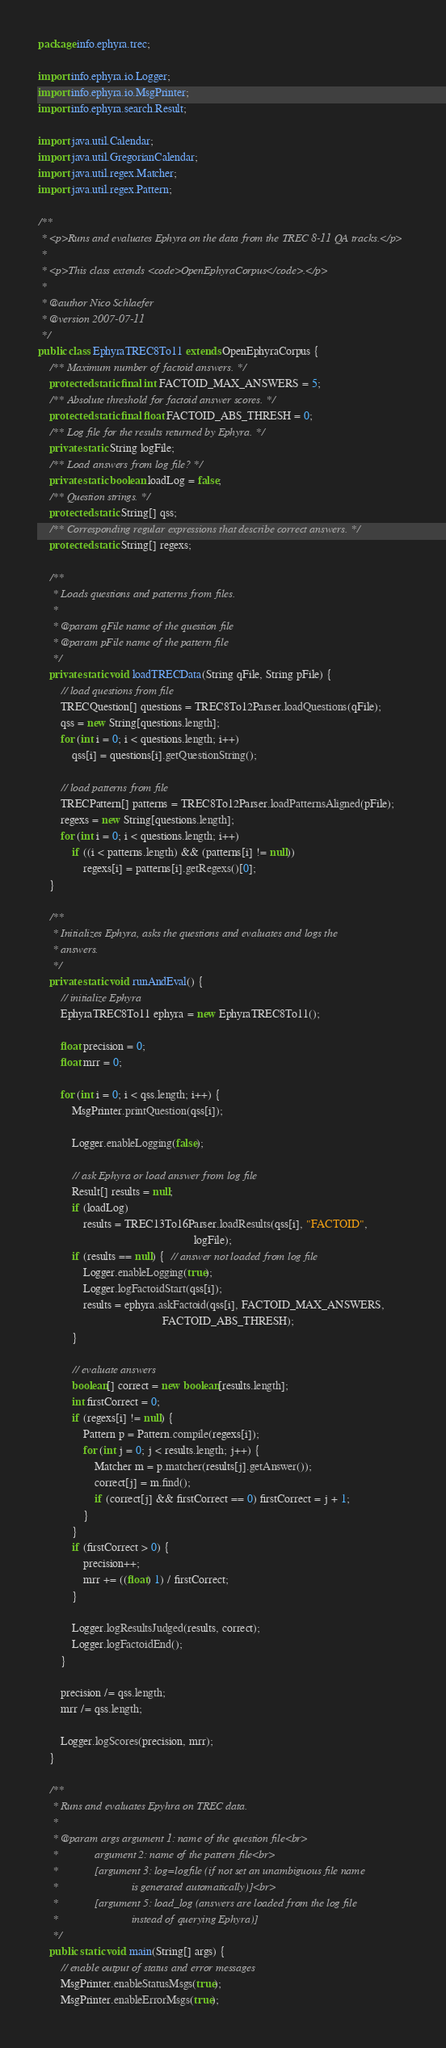<code> <loc_0><loc_0><loc_500><loc_500><_Java_>package info.ephyra.trec;

import info.ephyra.io.Logger;
import info.ephyra.io.MsgPrinter;
import info.ephyra.search.Result;

import java.util.Calendar;
import java.util.GregorianCalendar;
import java.util.regex.Matcher;
import java.util.regex.Pattern;

/**
 * <p>Runs and evaluates Ephyra on the data from the TREC 8-11 QA tracks.</p>
 * 
 * <p>This class extends <code>OpenEphyraCorpus</code>.</p>
 * 
 * @author Nico Schlaefer
 * @version 2007-07-11
 */
public class EphyraTREC8To11 extends OpenEphyraCorpus {
	/** Maximum number of factoid answers. */
	protected static final int FACTOID_MAX_ANSWERS = 5;
	/** Absolute threshold for factoid answer scores. */
	protected static final float FACTOID_ABS_THRESH = 0;
	/** Log file for the results returned by Ephyra. */
	private static String logFile;
	/** Load answers from log file? */
	private static boolean loadLog = false;
	/** Question strings. */
	protected static String[] qss;
	/** Corresponding regular expressions that describe correct answers. */
	protected static String[] regexs;
	
	/**
	 * Loads questions and patterns from files.
	 * 
	 * @param qFile name of the question file
	 * @param pFile name of the pattern file
	 */
	private static void loadTRECData(String qFile, String pFile) {
		// load questions from file
		TRECQuestion[] questions = TREC8To12Parser.loadQuestions(qFile);
		qss = new String[questions.length];
		for (int i = 0; i < questions.length; i++)
			qss[i] = questions[i].getQuestionString();
		
		// load patterns from file
		TRECPattern[] patterns = TREC8To12Parser.loadPatternsAligned(pFile);
		regexs = new String[questions.length];
		for (int i = 0; i < questions.length; i++)
			if ((i < patterns.length) && (patterns[i] != null))
				regexs[i] = patterns[i].getRegexs()[0];
	}
	
	/**
	 * Initializes Ephyra, asks the questions and evaluates and logs the
	 * answers.
	 */
	private static void runAndEval() {
		// initialize Ephyra
		EphyraTREC8To11 ephyra = new EphyraTREC8To11();
		
		float precision = 0;
		float mrr = 0;
		
		for (int i = 0; i < qss.length; i++) {
			MsgPrinter.printQuestion(qss[i]);
			
			Logger.enableLogging(false);
			
			// ask Ephyra or load answer from log file
			Result[] results = null;
			if (loadLog)
				results = TREC13To16Parser.loadResults(qss[i], "FACTOID",
													   logFile);
			if (results == null) {  // answer not loaded from log file
				Logger.enableLogging(true);
				Logger.logFactoidStart(qss[i]);
				results = ephyra.askFactoid(qss[i], FACTOID_MAX_ANSWERS,
											FACTOID_ABS_THRESH);
			}
			
			// evaluate answers
			boolean[] correct = new boolean[results.length];
			int firstCorrect = 0;
			if (regexs[i] != null) {
				Pattern p = Pattern.compile(regexs[i]);
				for (int j = 0; j < results.length; j++) {
					Matcher m = p.matcher(results[j].getAnswer());
					correct[j] = m.find();
					if (correct[j] && firstCorrect == 0) firstCorrect = j + 1;
				}
			}
			if (firstCorrect > 0) {
				precision++;
				mrr += ((float) 1) / firstCorrect;
			}
			
			Logger.logResultsJudged(results, correct);
			Logger.logFactoidEnd();
		}
		
		precision /= qss.length;
		mrr /= qss.length;
		
		Logger.logScores(precision, mrr);
	}
	
	/**
	 * Runs and evaluates Epyhra on TREC data.
	 * 
	 * @param args argument 1: name of the question file<br>
	 * 			   argument 2: name of the pattern file<br>
	 * 			   [argument 3: log=logfile (if not set an unambiguous file name
	 * 							is generated automatically)]<br>
	 * 			   [argument 5: load_log (answers are loaded from the log file
	 * 							instead of querying Ephyra)]
	 */
	public static void main(String[] args) {
		// enable output of status and error messages
		MsgPrinter.enableStatusMsgs(true);
		MsgPrinter.enableErrorMsgs(true);</code> 